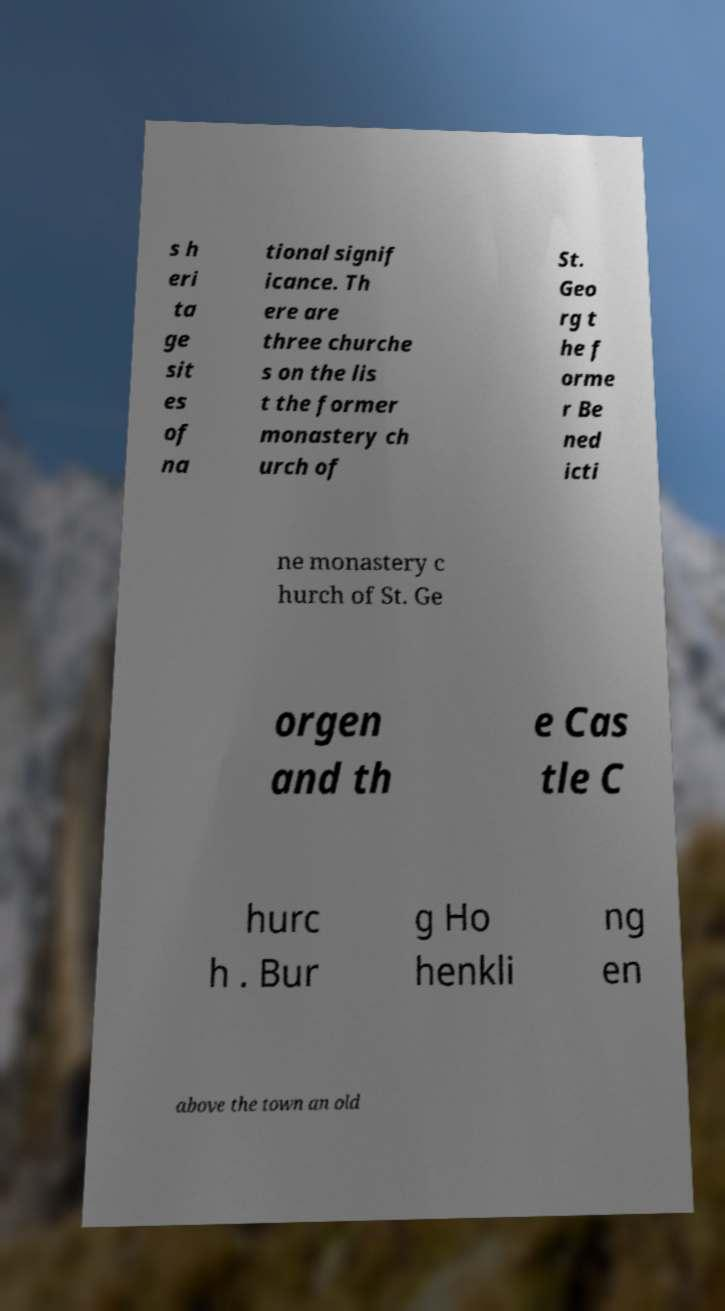Can you read and provide the text displayed in the image?This photo seems to have some interesting text. Can you extract and type it out for me? s h eri ta ge sit es of na tional signif icance. Th ere are three churche s on the lis t the former monastery ch urch of St. Geo rg t he f orme r Be ned icti ne monastery c hurch of St. Ge orgen and th e Cas tle C hurc h . Bur g Ho henkli ng en above the town an old 